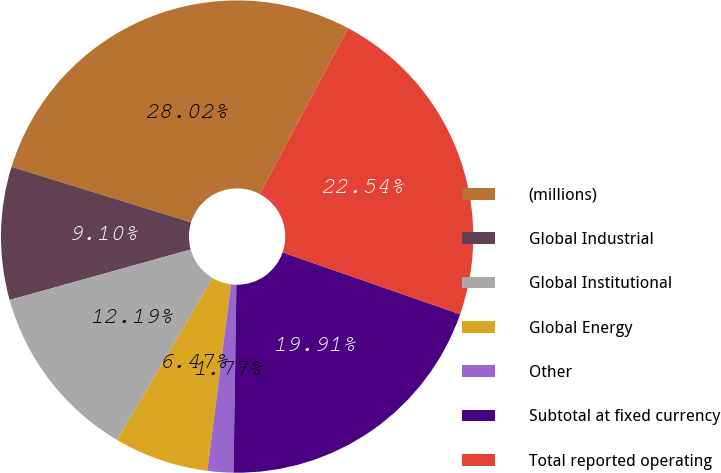<chart> <loc_0><loc_0><loc_500><loc_500><pie_chart><fcel>(millions)<fcel>Global Industrial<fcel>Global Institutional<fcel>Global Energy<fcel>Other<fcel>Subtotal at fixed currency<fcel>Total reported operating<nl><fcel>28.02%<fcel>9.1%<fcel>12.19%<fcel>6.47%<fcel>1.77%<fcel>19.91%<fcel>22.54%<nl></chart> 